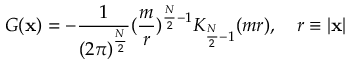<formula> <loc_0><loc_0><loc_500><loc_500>G ( x ) = - \frac { 1 } { ( 2 \pi ) ^ { \frac { N } { 2 } } } ( \frac { m } { r } ) ^ { \frac { N } { 2 } - 1 } K _ { \frac { N } { 2 } - 1 } ( m r ) , \quad r \equiv | x |</formula> 